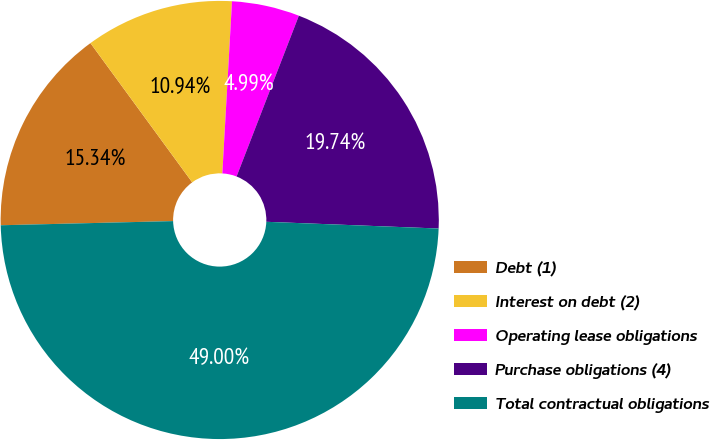Convert chart. <chart><loc_0><loc_0><loc_500><loc_500><pie_chart><fcel>Debt (1)<fcel>Interest on debt (2)<fcel>Operating lease obligations<fcel>Purchase obligations (4)<fcel>Total contractual obligations<nl><fcel>15.34%<fcel>10.94%<fcel>4.99%<fcel>19.74%<fcel>49.0%<nl></chart> 